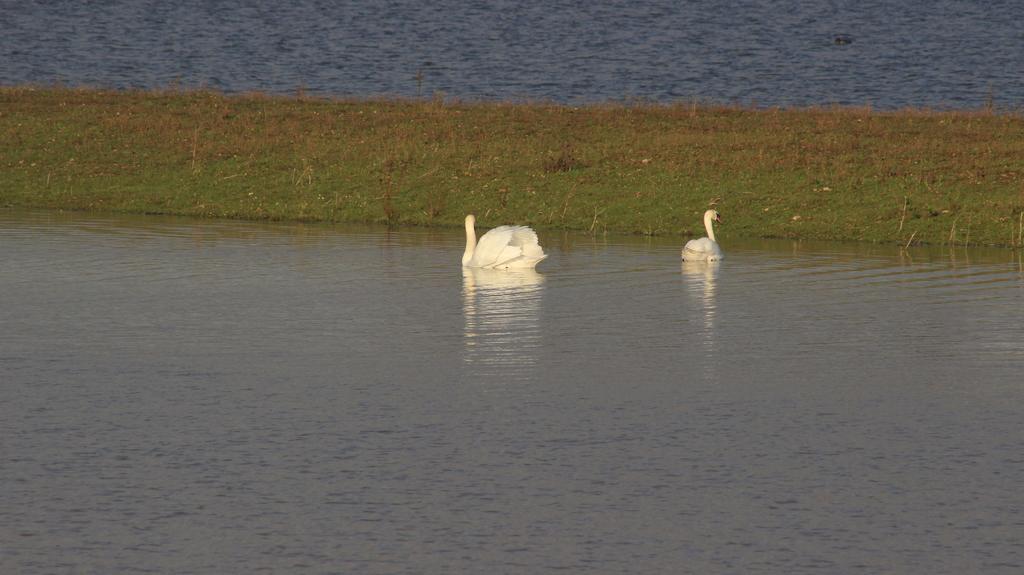In one or two sentences, can you explain what this image depicts? In this image there are swans on the water surface, in the middle there is a grassland. 